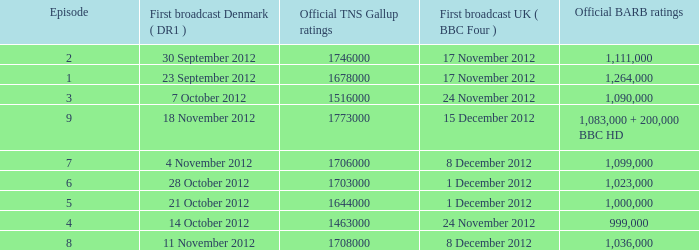When was the episode with a 1,036,000 BARB rating first aired in Denmark? 11 November 2012. 